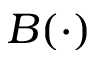<formula> <loc_0><loc_0><loc_500><loc_500>B ( \cdot )</formula> 